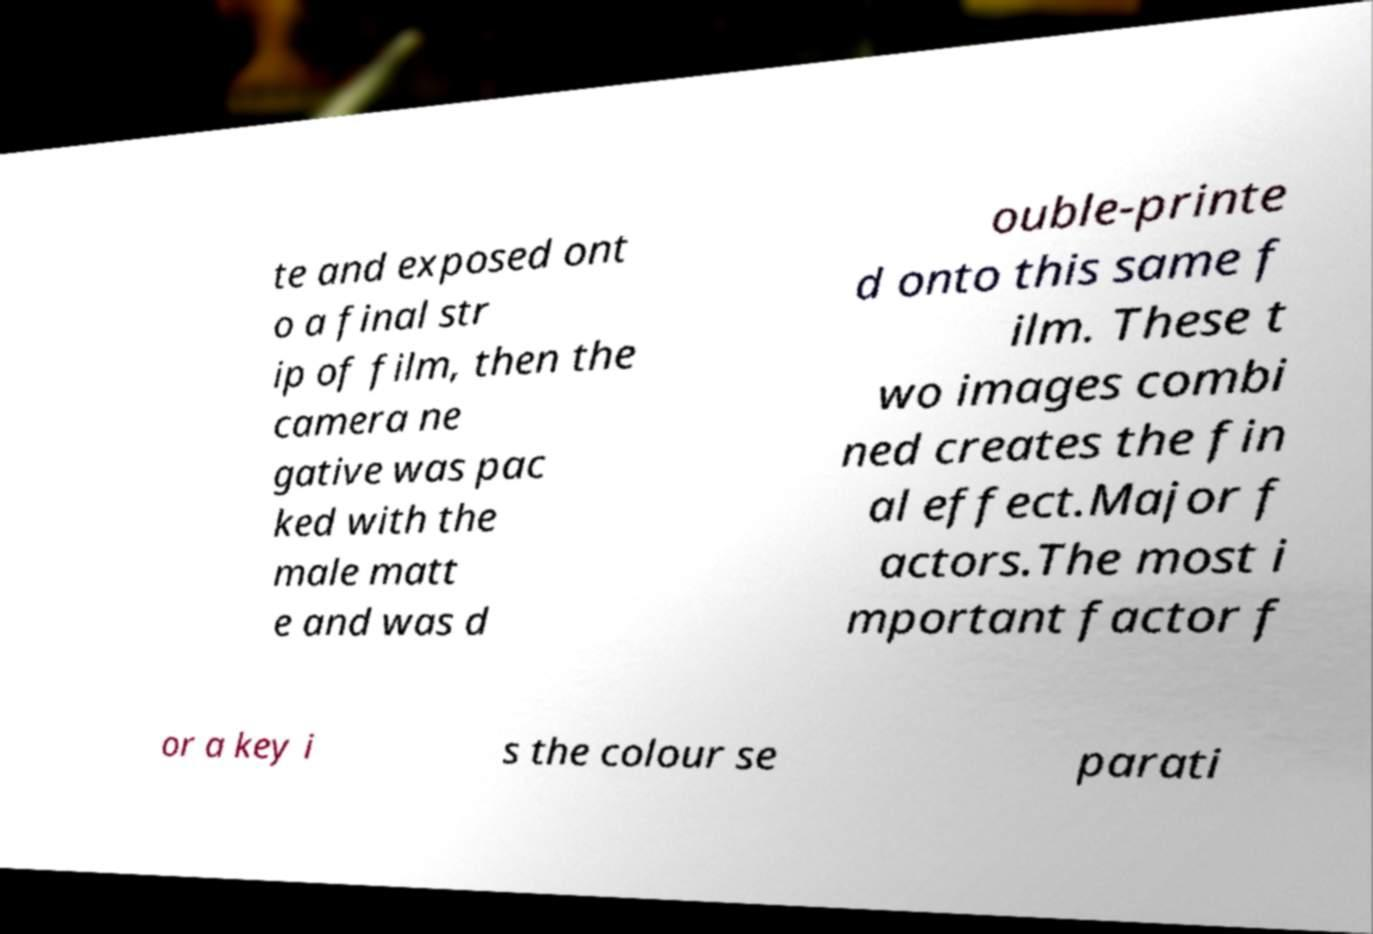Can you accurately transcribe the text from the provided image for me? te and exposed ont o a final str ip of film, then the camera ne gative was pac ked with the male matt e and was d ouble-printe d onto this same f ilm. These t wo images combi ned creates the fin al effect.Major f actors.The most i mportant factor f or a key i s the colour se parati 